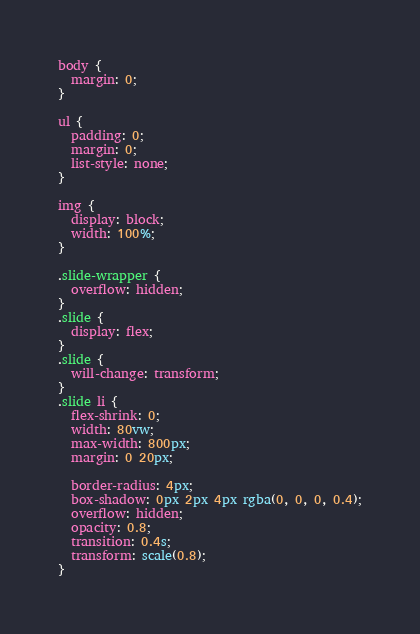Convert code to text. <code><loc_0><loc_0><loc_500><loc_500><_CSS_>body {
  margin: 0;
}

ul {
  padding: 0;
  margin: 0;
  list-style: none;
}

img {
  display: block;
  width: 100%;
}

.slide-wrapper {
  overflow: hidden;
}
.slide {
  display: flex;
}
.slide {
  will-change: transform;
}
.slide li {
  flex-shrink: 0;
  width: 80vw;
  max-width: 800px;
  margin: 0 20px;

  border-radius: 4px;
  box-shadow: 0px 2px 4px rgba(0, 0, 0, 0.4);
  overflow: hidden;
  opacity: 0.8;
  transition: 0.4s;
  transform: scale(0.8);
}</code> 